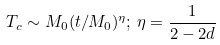Convert formula to latex. <formula><loc_0><loc_0><loc_500><loc_500>T _ { c } \sim M _ { 0 } ( t / M _ { 0 } ) ^ { \eta } ; \, \eta = \frac { 1 } { 2 - 2 d }</formula> 